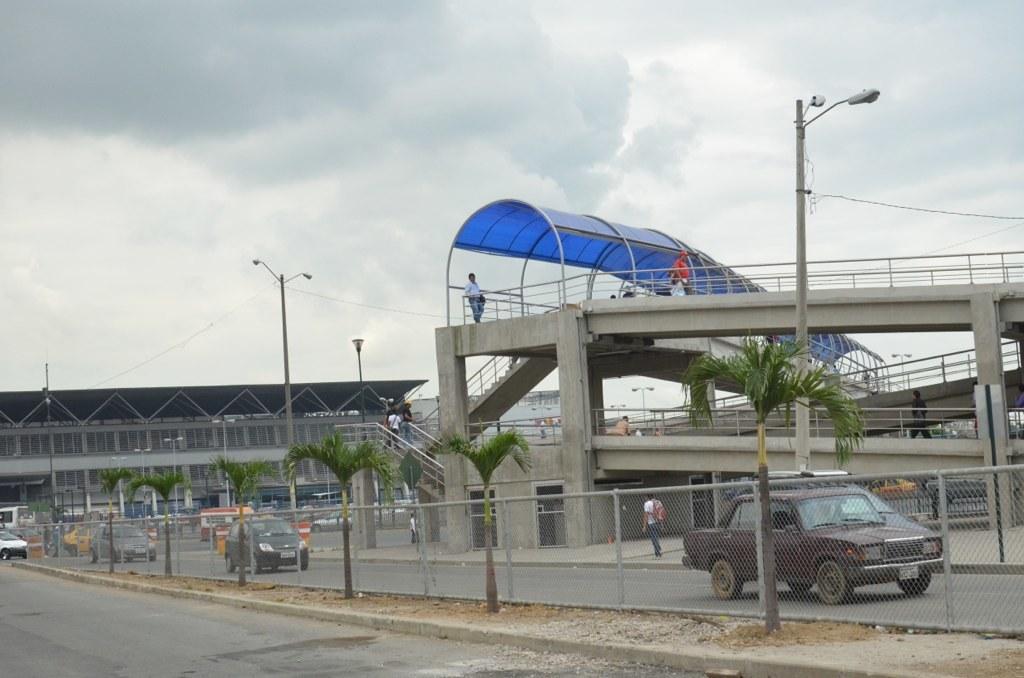Describe this image in one or two sentences. In this image, we can see vehicles, mesh, trees and roads. Here we can see light poles, sheds, stairs, railings, people, pillars and few objects. Background there is the sky. 